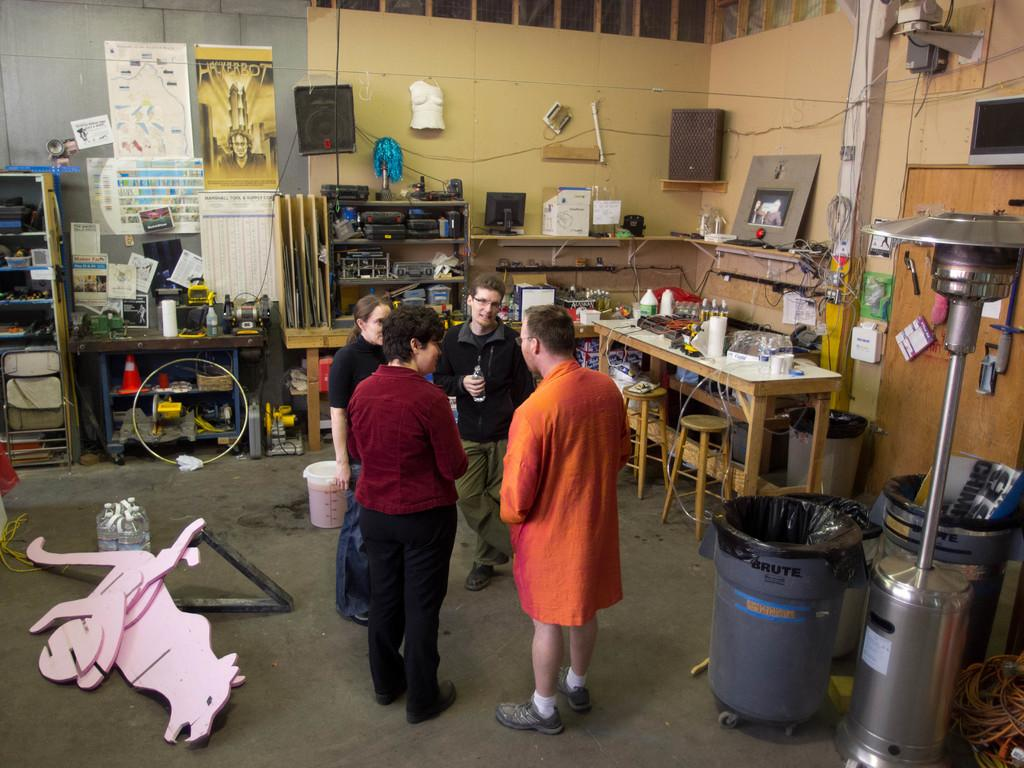How many people are in the image? There is a group of people in the image. Where are the people located? The people are standing in a room. What type of furniture is present in the room? There are stools and tables in the room. What type of decorations are in the room? There are posters in the room. Are there any other objects in the room besides the furniture and posters? Yes, there are other objects in the room. What type of legal form can be seen on the table in the image? There is no legal form present in the image; it only shows a group of people in a room with stools, tables, posters, and other objects. 